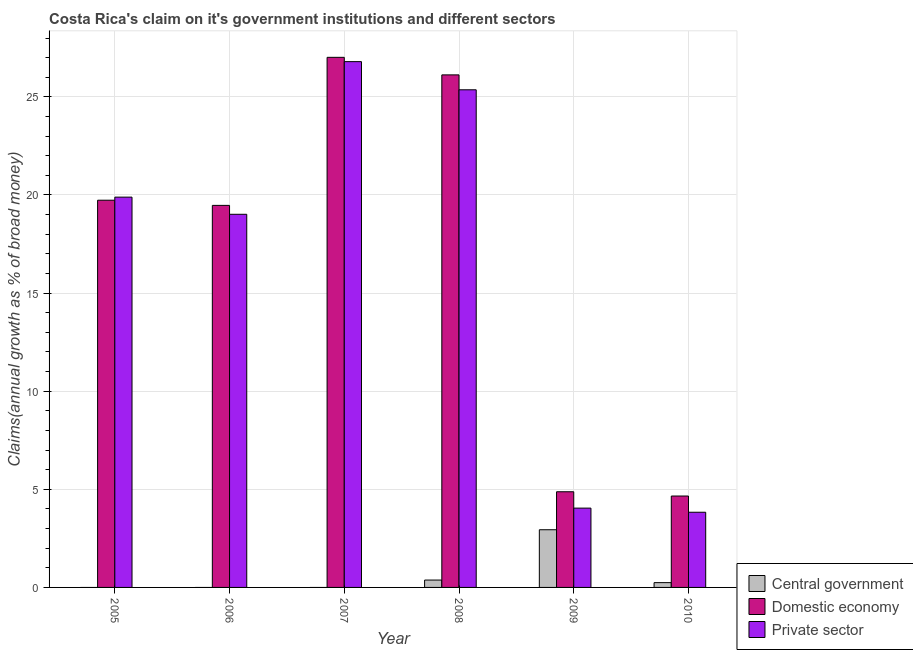Are the number of bars per tick equal to the number of legend labels?
Offer a terse response. No. Are the number of bars on each tick of the X-axis equal?
Your response must be concise. No. How many bars are there on the 1st tick from the right?
Your answer should be very brief. 3. In how many cases, is the number of bars for a given year not equal to the number of legend labels?
Your answer should be compact. 3. What is the percentage of claim on the private sector in 2007?
Offer a very short reply. 26.8. Across all years, what is the maximum percentage of claim on the central government?
Make the answer very short. 2.94. Across all years, what is the minimum percentage of claim on the private sector?
Your answer should be compact. 3.83. What is the total percentage of claim on the central government in the graph?
Make the answer very short. 3.56. What is the difference between the percentage of claim on the domestic economy in 2006 and that in 2007?
Provide a succinct answer. -7.55. What is the difference between the percentage of claim on the domestic economy in 2010 and the percentage of claim on the private sector in 2009?
Offer a terse response. -0.22. What is the average percentage of claim on the central government per year?
Keep it short and to the point. 0.59. In the year 2008, what is the difference between the percentage of claim on the domestic economy and percentage of claim on the central government?
Your response must be concise. 0. What is the ratio of the percentage of claim on the domestic economy in 2008 to that in 2010?
Ensure brevity in your answer.  5.61. Is the percentage of claim on the domestic economy in 2007 less than that in 2008?
Your answer should be compact. No. What is the difference between the highest and the second highest percentage of claim on the domestic economy?
Ensure brevity in your answer.  0.89. What is the difference between the highest and the lowest percentage of claim on the domestic economy?
Your answer should be very brief. 22.36. Are all the bars in the graph horizontal?
Provide a succinct answer. No. What is the difference between two consecutive major ticks on the Y-axis?
Give a very brief answer. 5. Are the values on the major ticks of Y-axis written in scientific E-notation?
Offer a very short reply. No. Does the graph contain any zero values?
Provide a succinct answer. Yes. Where does the legend appear in the graph?
Ensure brevity in your answer.  Bottom right. How many legend labels are there?
Provide a succinct answer. 3. What is the title of the graph?
Give a very brief answer. Costa Rica's claim on it's government institutions and different sectors. Does "Financial account" appear as one of the legend labels in the graph?
Your answer should be very brief. No. What is the label or title of the Y-axis?
Make the answer very short. Claims(annual growth as % of broad money). What is the Claims(annual growth as % of broad money) in Central government in 2005?
Offer a terse response. 0. What is the Claims(annual growth as % of broad money) of Domestic economy in 2005?
Make the answer very short. 19.73. What is the Claims(annual growth as % of broad money) of Private sector in 2005?
Your answer should be very brief. 19.89. What is the Claims(annual growth as % of broad money) of Domestic economy in 2006?
Offer a very short reply. 19.47. What is the Claims(annual growth as % of broad money) of Private sector in 2006?
Your answer should be compact. 19.02. What is the Claims(annual growth as % of broad money) of Central government in 2007?
Provide a short and direct response. 0. What is the Claims(annual growth as % of broad money) in Domestic economy in 2007?
Provide a succinct answer. 27.02. What is the Claims(annual growth as % of broad money) in Private sector in 2007?
Make the answer very short. 26.8. What is the Claims(annual growth as % of broad money) in Central government in 2008?
Offer a terse response. 0.38. What is the Claims(annual growth as % of broad money) in Domestic economy in 2008?
Provide a short and direct response. 26.12. What is the Claims(annual growth as % of broad money) of Private sector in 2008?
Keep it short and to the point. 25.36. What is the Claims(annual growth as % of broad money) of Central government in 2009?
Your answer should be very brief. 2.94. What is the Claims(annual growth as % of broad money) in Domestic economy in 2009?
Offer a very short reply. 4.88. What is the Claims(annual growth as % of broad money) of Private sector in 2009?
Provide a short and direct response. 4.04. What is the Claims(annual growth as % of broad money) of Central government in 2010?
Keep it short and to the point. 0.24. What is the Claims(annual growth as % of broad money) in Domestic economy in 2010?
Offer a very short reply. 4.66. What is the Claims(annual growth as % of broad money) of Private sector in 2010?
Provide a succinct answer. 3.83. Across all years, what is the maximum Claims(annual growth as % of broad money) in Central government?
Make the answer very short. 2.94. Across all years, what is the maximum Claims(annual growth as % of broad money) in Domestic economy?
Make the answer very short. 27.02. Across all years, what is the maximum Claims(annual growth as % of broad money) in Private sector?
Provide a succinct answer. 26.8. Across all years, what is the minimum Claims(annual growth as % of broad money) of Central government?
Your answer should be very brief. 0. Across all years, what is the minimum Claims(annual growth as % of broad money) in Domestic economy?
Your answer should be compact. 4.66. Across all years, what is the minimum Claims(annual growth as % of broad money) in Private sector?
Your response must be concise. 3.83. What is the total Claims(annual growth as % of broad money) of Central government in the graph?
Your answer should be compact. 3.56. What is the total Claims(annual growth as % of broad money) of Domestic economy in the graph?
Give a very brief answer. 101.87. What is the total Claims(annual growth as % of broad money) in Private sector in the graph?
Provide a succinct answer. 98.94. What is the difference between the Claims(annual growth as % of broad money) of Domestic economy in 2005 and that in 2006?
Ensure brevity in your answer.  0.26. What is the difference between the Claims(annual growth as % of broad money) of Private sector in 2005 and that in 2006?
Your response must be concise. 0.87. What is the difference between the Claims(annual growth as % of broad money) of Domestic economy in 2005 and that in 2007?
Offer a terse response. -7.28. What is the difference between the Claims(annual growth as % of broad money) of Private sector in 2005 and that in 2007?
Your answer should be compact. -6.9. What is the difference between the Claims(annual growth as % of broad money) of Domestic economy in 2005 and that in 2008?
Your answer should be compact. -6.39. What is the difference between the Claims(annual growth as % of broad money) of Private sector in 2005 and that in 2008?
Your answer should be very brief. -5.47. What is the difference between the Claims(annual growth as % of broad money) in Domestic economy in 2005 and that in 2009?
Give a very brief answer. 14.86. What is the difference between the Claims(annual growth as % of broad money) in Private sector in 2005 and that in 2009?
Provide a short and direct response. 15.85. What is the difference between the Claims(annual growth as % of broad money) of Domestic economy in 2005 and that in 2010?
Your response must be concise. 15.08. What is the difference between the Claims(annual growth as % of broad money) in Private sector in 2005 and that in 2010?
Your response must be concise. 16.06. What is the difference between the Claims(annual growth as % of broad money) of Domestic economy in 2006 and that in 2007?
Your answer should be compact. -7.55. What is the difference between the Claims(annual growth as % of broad money) in Private sector in 2006 and that in 2007?
Your answer should be compact. -7.78. What is the difference between the Claims(annual growth as % of broad money) in Domestic economy in 2006 and that in 2008?
Make the answer very short. -6.65. What is the difference between the Claims(annual growth as % of broad money) of Private sector in 2006 and that in 2008?
Make the answer very short. -6.34. What is the difference between the Claims(annual growth as % of broad money) of Domestic economy in 2006 and that in 2009?
Provide a short and direct response. 14.59. What is the difference between the Claims(annual growth as % of broad money) of Private sector in 2006 and that in 2009?
Provide a short and direct response. 14.97. What is the difference between the Claims(annual growth as % of broad money) of Domestic economy in 2006 and that in 2010?
Provide a succinct answer. 14.81. What is the difference between the Claims(annual growth as % of broad money) in Private sector in 2006 and that in 2010?
Your answer should be compact. 15.18. What is the difference between the Claims(annual growth as % of broad money) in Domestic economy in 2007 and that in 2008?
Offer a very short reply. 0.89. What is the difference between the Claims(annual growth as % of broad money) of Private sector in 2007 and that in 2008?
Your answer should be very brief. 1.43. What is the difference between the Claims(annual growth as % of broad money) in Domestic economy in 2007 and that in 2009?
Provide a short and direct response. 22.14. What is the difference between the Claims(annual growth as % of broad money) in Private sector in 2007 and that in 2009?
Offer a very short reply. 22.75. What is the difference between the Claims(annual growth as % of broad money) of Domestic economy in 2007 and that in 2010?
Your answer should be very brief. 22.36. What is the difference between the Claims(annual growth as % of broad money) in Private sector in 2007 and that in 2010?
Provide a short and direct response. 22.96. What is the difference between the Claims(annual growth as % of broad money) of Central government in 2008 and that in 2009?
Give a very brief answer. -2.56. What is the difference between the Claims(annual growth as % of broad money) in Domestic economy in 2008 and that in 2009?
Provide a succinct answer. 21.25. What is the difference between the Claims(annual growth as % of broad money) in Private sector in 2008 and that in 2009?
Your response must be concise. 21.32. What is the difference between the Claims(annual growth as % of broad money) of Central government in 2008 and that in 2010?
Ensure brevity in your answer.  0.13. What is the difference between the Claims(annual growth as % of broad money) of Domestic economy in 2008 and that in 2010?
Provide a short and direct response. 21.46. What is the difference between the Claims(annual growth as % of broad money) in Private sector in 2008 and that in 2010?
Make the answer very short. 21.53. What is the difference between the Claims(annual growth as % of broad money) of Central government in 2009 and that in 2010?
Provide a succinct answer. 2.7. What is the difference between the Claims(annual growth as % of broad money) of Domestic economy in 2009 and that in 2010?
Provide a succinct answer. 0.22. What is the difference between the Claims(annual growth as % of broad money) of Private sector in 2009 and that in 2010?
Your answer should be very brief. 0.21. What is the difference between the Claims(annual growth as % of broad money) of Domestic economy in 2005 and the Claims(annual growth as % of broad money) of Private sector in 2006?
Give a very brief answer. 0.72. What is the difference between the Claims(annual growth as % of broad money) in Domestic economy in 2005 and the Claims(annual growth as % of broad money) in Private sector in 2007?
Provide a succinct answer. -7.06. What is the difference between the Claims(annual growth as % of broad money) of Domestic economy in 2005 and the Claims(annual growth as % of broad money) of Private sector in 2008?
Offer a terse response. -5.63. What is the difference between the Claims(annual growth as % of broad money) of Domestic economy in 2005 and the Claims(annual growth as % of broad money) of Private sector in 2009?
Give a very brief answer. 15.69. What is the difference between the Claims(annual growth as % of broad money) in Domestic economy in 2005 and the Claims(annual growth as % of broad money) in Private sector in 2010?
Give a very brief answer. 15.9. What is the difference between the Claims(annual growth as % of broad money) of Domestic economy in 2006 and the Claims(annual growth as % of broad money) of Private sector in 2007?
Give a very brief answer. -7.33. What is the difference between the Claims(annual growth as % of broad money) of Domestic economy in 2006 and the Claims(annual growth as % of broad money) of Private sector in 2008?
Offer a terse response. -5.89. What is the difference between the Claims(annual growth as % of broad money) in Domestic economy in 2006 and the Claims(annual growth as % of broad money) in Private sector in 2009?
Ensure brevity in your answer.  15.43. What is the difference between the Claims(annual growth as % of broad money) in Domestic economy in 2006 and the Claims(annual growth as % of broad money) in Private sector in 2010?
Ensure brevity in your answer.  15.64. What is the difference between the Claims(annual growth as % of broad money) in Domestic economy in 2007 and the Claims(annual growth as % of broad money) in Private sector in 2008?
Make the answer very short. 1.65. What is the difference between the Claims(annual growth as % of broad money) of Domestic economy in 2007 and the Claims(annual growth as % of broad money) of Private sector in 2009?
Ensure brevity in your answer.  22.97. What is the difference between the Claims(annual growth as % of broad money) of Domestic economy in 2007 and the Claims(annual growth as % of broad money) of Private sector in 2010?
Provide a short and direct response. 23.18. What is the difference between the Claims(annual growth as % of broad money) in Central government in 2008 and the Claims(annual growth as % of broad money) in Domestic economy in 2009?
Make the answer very short. -4.5. What is the difference between the Claims(annual growth as % of broad money) of Central government in 2008 and the Claims(annual growth as % of broad money) of Private sector in 2009?
Make the answer very short. -3.67. What is the difference between the Claims(annual growth as % of broad money) in Domestic economy in 2008 and the Claims(annual growth as % of broad money) in Private sector in 2009?
Offer a terse response. 22.08. What is the difference between the Claims(annual growth as % of broad money) in Central government in 2008 and the Claims(annual growth as % of broad money) in Domestic economy in 2010?
Your response must be concise. -4.28. What is the difference between the Claims(annual growth as % of broad money) in Central government in 2008 and the Claims(annual growth as % of broad money) in Private sector in 2010?
Provide a succinct answer. -3.46. What is the difference between the Claims(annual growth as % of broad money) in Domestic economy in 2008 and the Claims(annual growth as % of broad money) in Private sector in 2010?
Your answer should be very brief. 22.29. What is the difference between the Claims(annual growth as % of broad money) of Central government in 2009 and the Claims(annual growth as % of broad money) of Domestic economy in 2010?
Your answer should be compact. -1.72. What is the difference between the Claims(annual growth as % of broad money) in Central government in 2009 and the Claims(annual growth as % of broad money) in Private sector in 2010?
Offer a terse response. -0.89. What is the difference between the Claims(annual growth as % of broad money) in Domestic economy in 2009 and the Claims(annual growth as % of broad money) in Private sector in 2010?
Offer a terse response. 1.04. What is the average Claims(annual growth as % of broad money) of Central government per year?
Keep it short and to the point. 0.59. What is the average Claims(annual growth as % of broad money) of Domestic economy per year?
Give a very brief answer. 16.98. What is the average Claims(annual growth as % of broad money) in Private sector per year?
Offer a very short reply. 16.49. In the year 2005, what is the difference between the Claims(annual growth as % of broad money) in Domestic economy and Claims(annual growth as % of broad money) in Private sector?
Make the answer very short. -0.16. In the year 2006, what is the difference between the Claims(annual growth as % of broad money) of Domestic economy and Claims(annual growth as % of broad money) of Private sector?
Ensure brevity in your answer.  0.45. In the year 2007, what is the difference between the Claims(annual growth as % of broad money) in Domestic economy and Claims(annual growth as % of broad money) in Private sector?
Ensure brevity in your answer.  0.22. In the year 2008, what is the difference between the Claims(annual growth as % of broad money) in Central government and Claims(annual growth as % of broad money) in Domestic economy?
Make the answer very short. -25.75. In the year 2008, what is the difference between the Claims(annual growth as % of broad money) of Central government and Claims(annual growth as % of broad money) of Private sector?
Offer a very short reply. -24.99. In the year 2008, what is the difference between the Claims(annual growth as % of broad money) of Domestic economy and Claims(annual growth as % of broad money) of Private sector?
Provide a short and direct response. 0.76. In the year 2009, what is the difference between the Claims(annual growth as % of broad money) of Central government and Claims(annual growth as % of broad money) of Domestic economy?
Ensure brevity in your answer.  -1.94. In the year 2009, what is the difference between the Claims(annual growth as % of broad money) in Central government and Claims(annual growth as % of broad money) in Private sector?
Give a very brief answer. -1.1. In the year 2009, what is the difference between the Claims(annual growth as % of broad money) of Domestic economy and Claims(annual growth as % of broad money) of Private sector?
Give a very brief answer. 0.83. In the year 2010, what is the difference between the Claims(annual growth as % of broad money) of Central government and Claims(annual growth as % of broad money) of Domestic economy?
Ensure brevity in your answer.  -4.41. In the year 2010, what is the difference between the Claims(annual growth as % of broad money) in Central government and Claims(annual growth as % of broad money) in Private sector?
Give a very brief answer. -3.59. In the year 2010, what is the difference between the Claims(annual growth as % of broad money) of Domestic economy and Claims(annual growth as % of broad money) of Private sector?
Your response must be concise. 0.83. What is the ratio of the Claims(annual growth as % of broad money) of Domestic economy in 2005 to that in 2006?
Provide a short and direct response. 1.01. What is the ratio of the Claims(annual growth as % of broad money) in Private sector in 2005 to that in 2006?
Your answer should be very brief. 1.05. What is the ratio of the Claims(annual growth as % of broad money) of Domestic economy in 2005 to that in 2007?
Offer a terse response. 0.73. What is the ratio of the Claims(annual growth as % of broad money) of Private sector in 2005 to that in 2007?
Make the answer very short. 0.74. What is the ratio of the Claims(annual growth as % of broad money) of Domestic economy in 2005 to that in 2008?
Your answer should be compact. 0.76. What is the ratio of the Claims(annual growth as % of broad money) of Private sector in 2005 to that in 2008?
Your answer should be very brief. 0.78. What is the ratio of the Claims(annual growth as % of broad money) of Domestic economy in 2005 to that in 2009?
Give a very brief answer. 4.05. What is the ratio of the Claims(annual growth as % of broad money) of Private sector in 2005 to that in 2009?
Provide a succinct answer. 4.92. What is the ratio of the Claims(annual growth as % of broad money) of Domestic economy in 2005 to that in 2010?
Offer a very short reply. 4.24. What is the ratio of the Claims(annual growth as % of broad money) of Private sector in 2005 to that in 2010?
Your response must be concise. 5.19. What is the ratio of the Claims(annual growth as % of broad money) in Domestic economy in 2006 to that in 2007?
Keep it short and to the point. 0.72. What is the ratio of the Claims(annual growth as % of broad money) in Private sector in 2006 to that in 2007?
Ensure brevity in your answer.  0.71. What is the ratio of the Claims(annual growth as % of broad money) of Domestic economy in 2006 to that in 2008?
Keep it short and to the point. 0.75. What is the ratio of the Claims(annual growth as % of broad money) in Private sector in 2006 to that in 2008?
Offer a very short reply. 0.75. What is the ratio of the Claims(annual growth as % of broad money) in Domestic economy in 2006 to that in 2009?
Ensure brevity in your answer.  3.99. What is the ratio of the Claims(annual growth as % of broad money) of Private sector in 2006 to that in 2009?
Your answer should be very brief. 4.71. What is the ratio of the Claims(annual growth as % of broad money) of Domestic economy in 2006 to that in 2010?
Your answer should be compact. 4.18. What is the ratio of the Claims(annual growth as % of broad money) in Private sector in 2006 to that in 2010?
Your response must be concise. 4.96. What is the ratio of the Claims(annual growth as % of broad money) in Domestic economy in 2007 to that in 2008?
Offer a very short reply. 1.03. What is the ratio of the Claims(annual growth as % of broad money) in Private sector in 2007 to that in 2008?
Provide a short and direct response. 1.06. What is the ratio of the Claims(annual growth as % of broad money) in Domestic economy in 2007 to that in 2009?
Keep it short and to the point. 5.54. What is the ratio of the Claims(annual growth as % of broad money) of Private sector in 2007 to that in 2009?
Ensure brevity in your answer.  6.63. What is the ratio of the Claims(annual growth as % of broad money) of Domestic economy in 2007 to that in 2010?
Keep it short and to the point. 5.8. What is the ratio of the Claims(annual growth as % of broad money) of Private sector in 2007 to that in 2010?
Ensure brevity in your answer.  6.99. What is the ratio of the Claims(annual growth as % of broad money) of Central government in 2008 to that in 2009?
Offer a terse response. 0.13. What is the ratio of the Claims(annual growth as % of broad money) of Domestic economy in 2008 to that in 2009?
Your answer should be very brief. 5.36. What is the ratio of the Claims(annual growth as % of broad money) in Private sector in 2008 to that in 2009?
Offer a very short reply. 6.28. What is the ratio of the Claims(annual growth as % of broad money) of Central government in 2008 to that in 2010?
Keep it short and to the point. 1.54. What is the ratio of the Claims(annual growth as % of broad money) of Domestic economy in 2008 to that in 2010?
Provide a succinct answer. 5.61. What is the ratio of the Claims(annual growth as % of broad money) of Private sector in 2008 to that in 2010?
Give a very brief answer. 6.62. What is the ratio of the Claims(annual growth as % of broad money) of Central government in 2009 to that in 2010?
Offer a very short reply. 12.02. What is the ratio of the Claims(annual growth as % of broad money) in Domestic economy in 2009 to that in 2010?
Provide a short and direct response. 1.05. What is the ratio of the Claims(annual growth as % of broad money) of Private sector in 2009 to that in 2010?
Your answer should be very brief. 1.05. What is the difference between the highest and the second highest Claims(annual growth as % of broad money) of Central government?
Offer a terse response. 2.56. What is the difference between the highest and the second highest Claims(annual growth as % of broad money) of Domestic economy?
Offer a terse response. 0.89. What is the difference between the highest and the second highest Claims(annual growth as % of broad money) in Private sector?
Offer a very short reply. 1.43. What is the difference between the highest and the lowest Claims(annual growth as % of broad money) in Central government?
Provide a short and direct response. 2.94. What is the difference between the highest and the lowest Claims(annual growth as % of broad money) of Domestic economy?
Offer a terse response. 22.36. What is the difference between the highest and the lowest Claims(annual growth as % of broad money) in Private sector?
Provide a short and direct response. 22.96. 